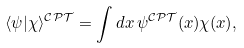<formula> <loc_0><loc_0><loc_500><loc_500>\langle \psi | \chi \rangle ^ { \mathcal { C P T } } = \int d x \, \psi ^ { \mathcal { C P T } } ( x ) \chi ( x ) ,</formula> 